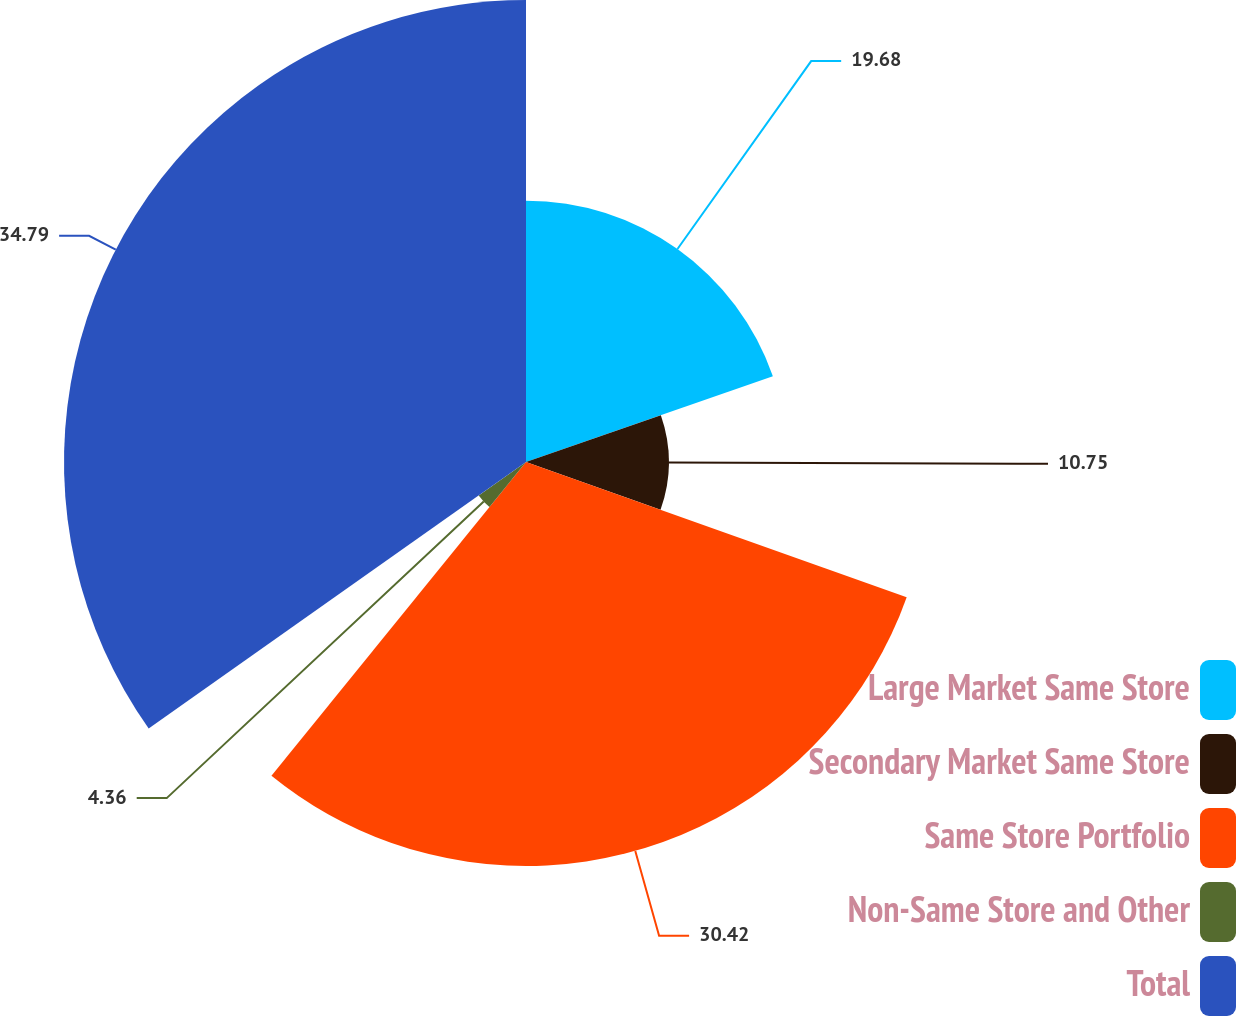<chart> <loc_0><loc_0><loc_500><loc_500><pie_chart><fcel>Large Market Same Store<fcel>Secondary Market Same Store<fcel>Same Store Portfolio<fcel>Non-Same Store and Other<fcel>Total<nl><fcel>19.68%<fcel>10.75%<fcel>30.42%<fcel>4.36%<fcel>34.79%<nl></chart> 